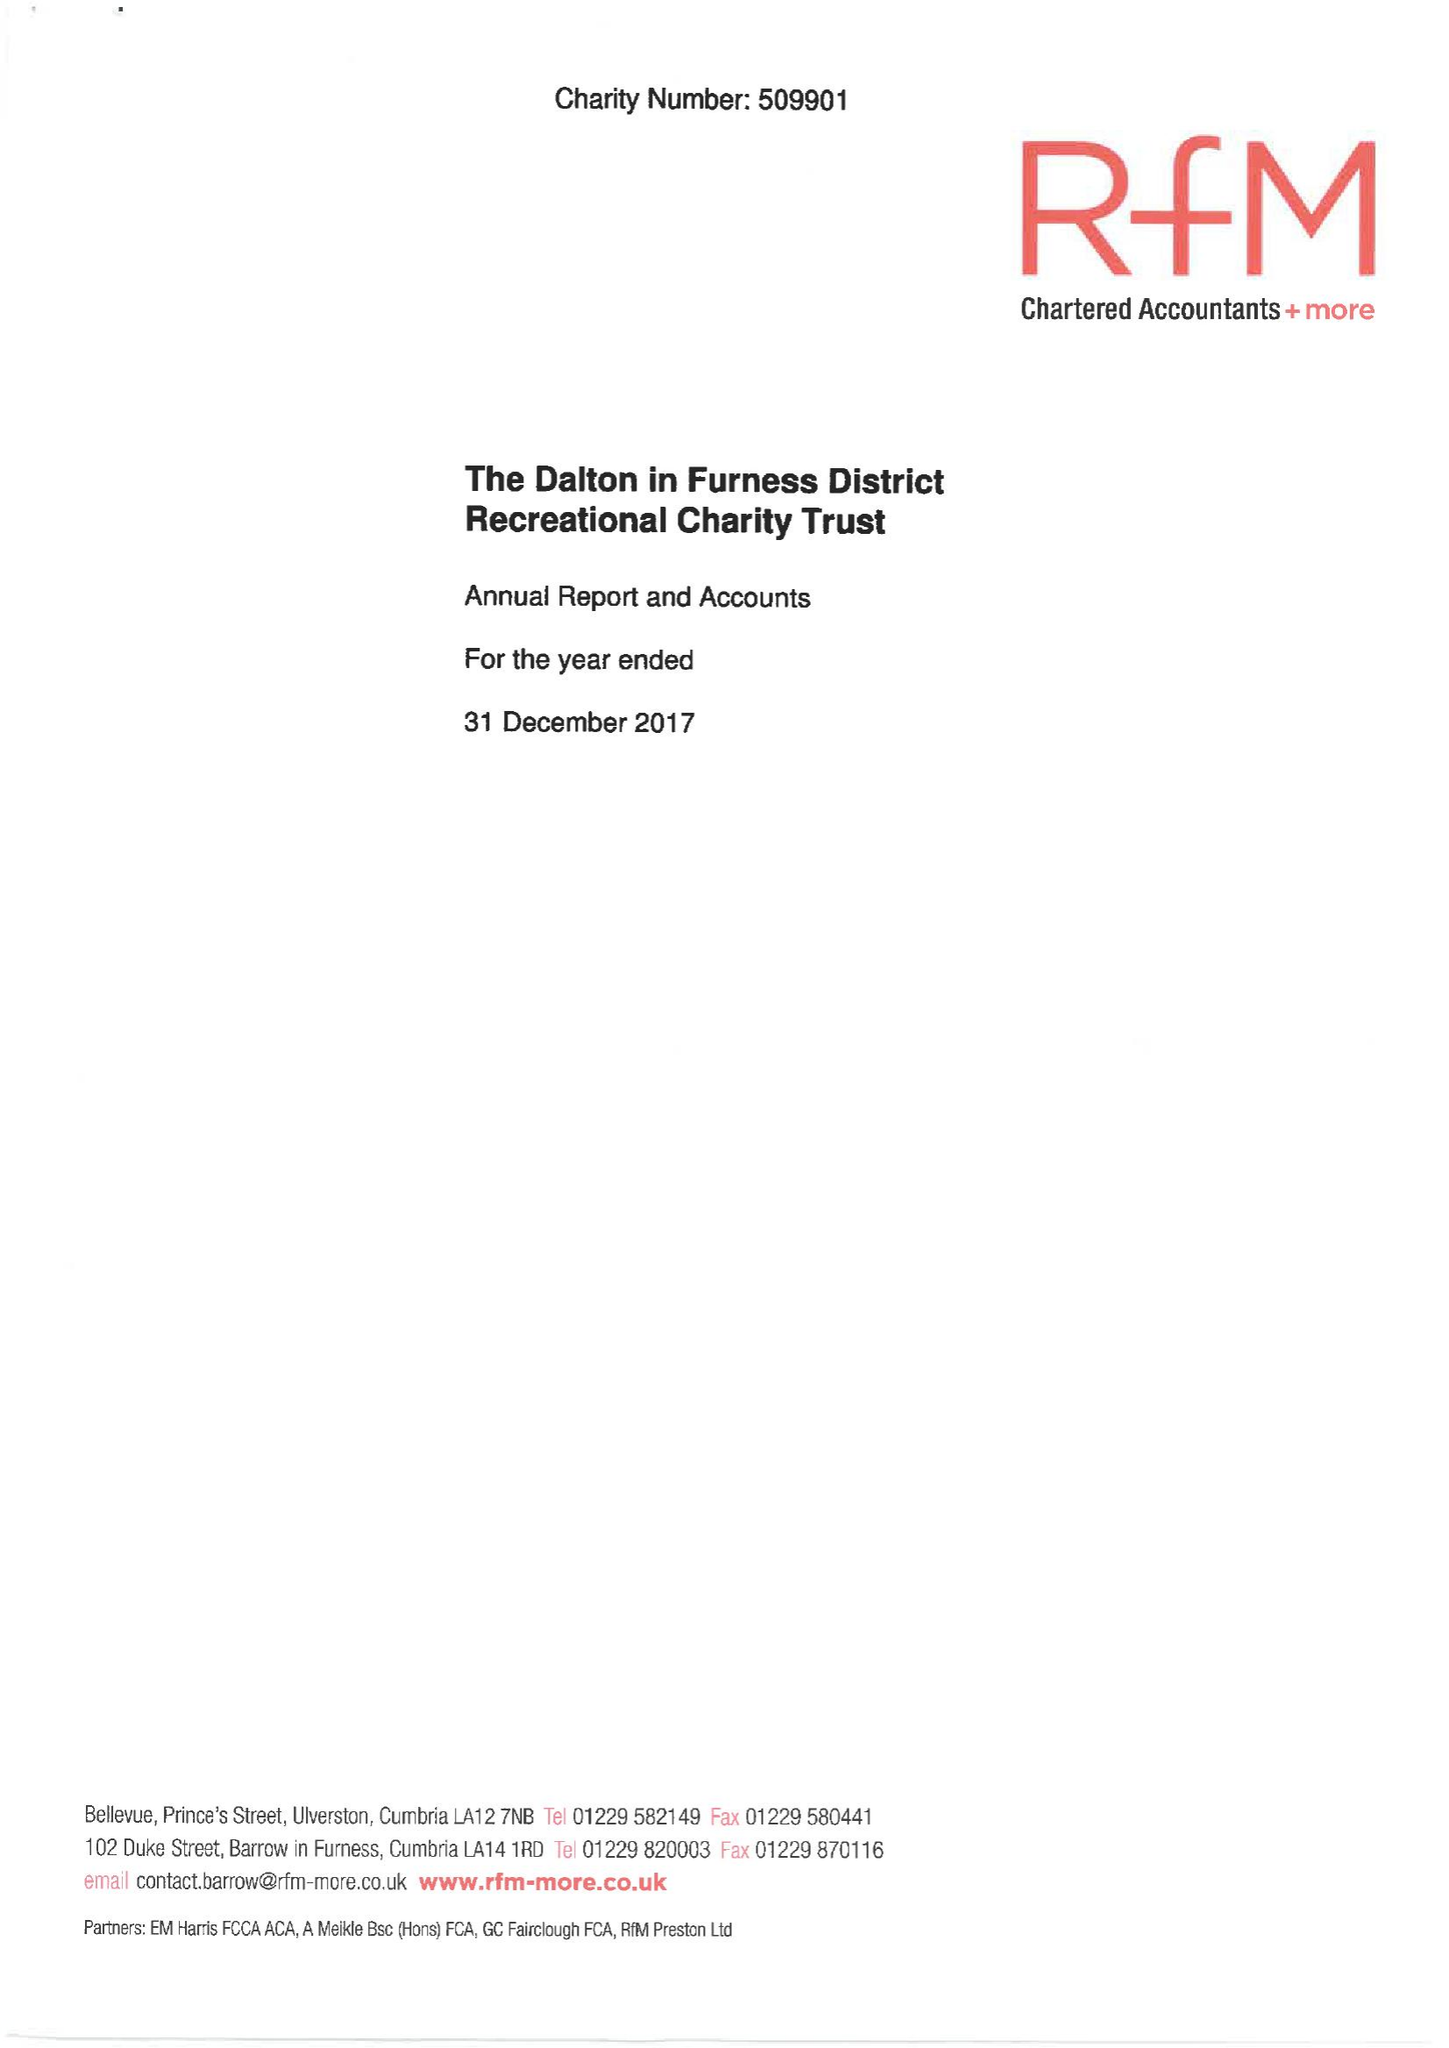What is the value for the address__post_town?
Answer the question using a single word or phrase. KIRKBY-IN-FURNESS 